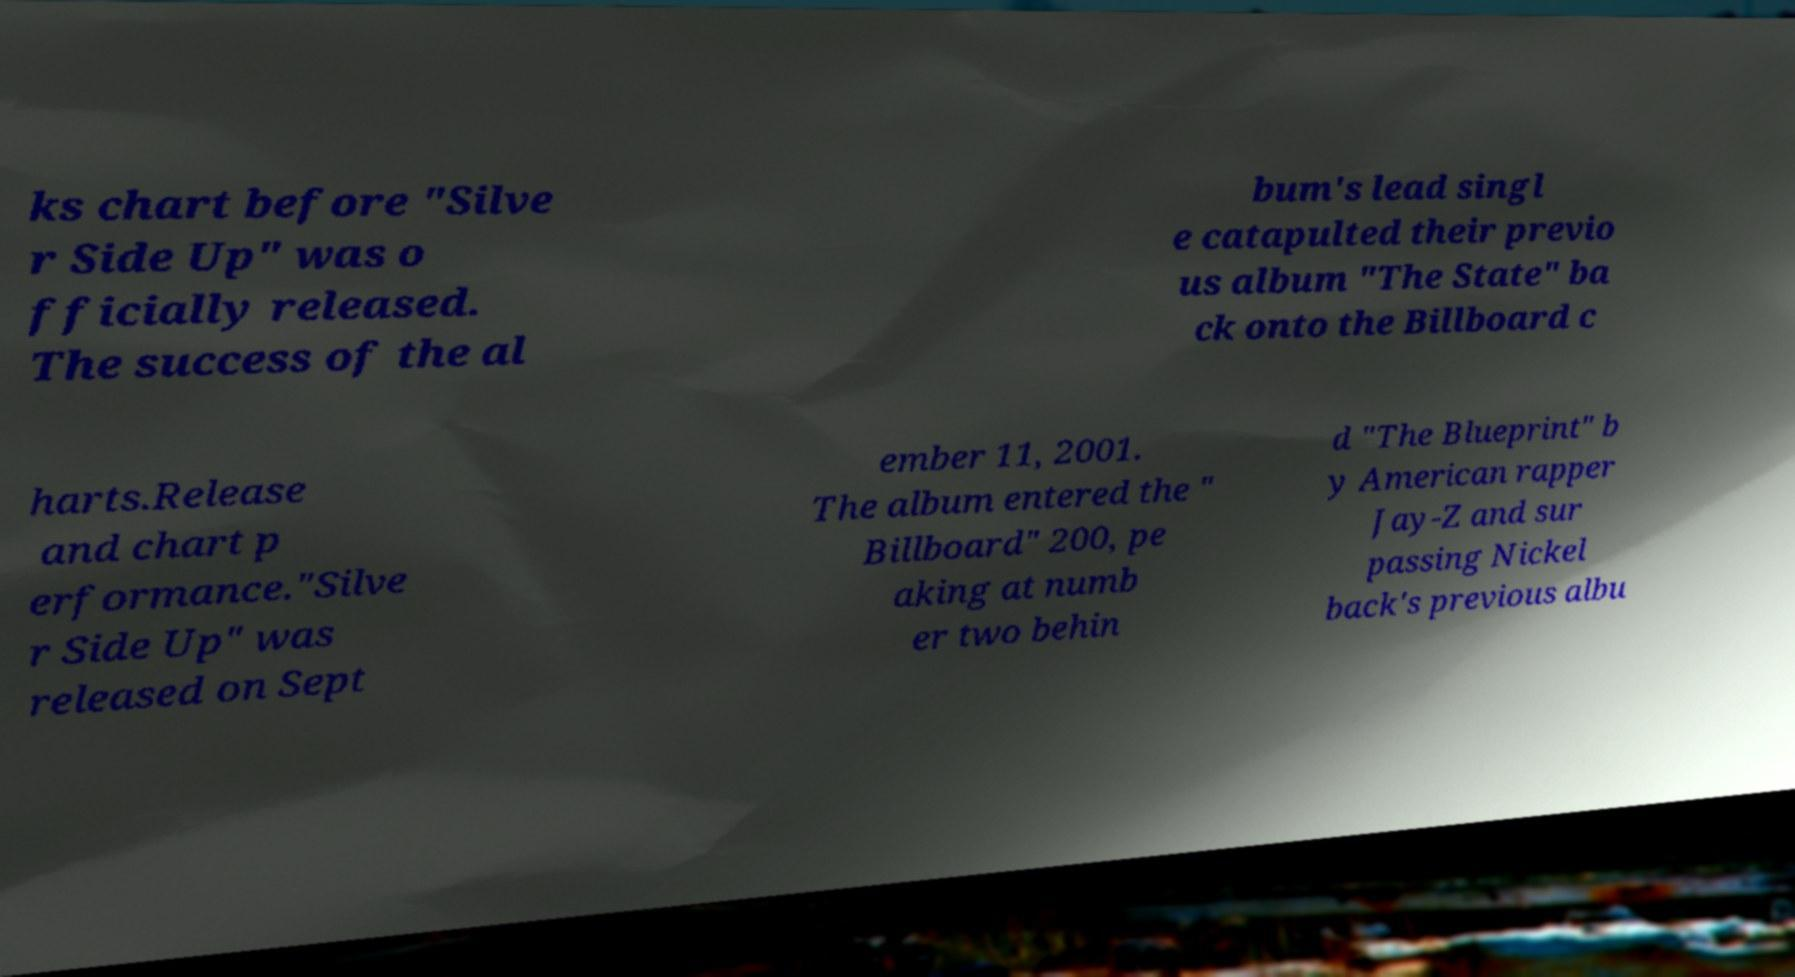For documentation purposes, I need the text within this image transcribed. Could you provide that? ks chart before "Silve r Side Up" was o fficially released. The success of the al bum's lead singl e catapulted their previo us album "The State" ba ck onto the Billboard c harts.Release and chart p erformance."Silve r Side Up" was released on Sept ember 11, 2001. The album entered the " Billboard" 200, pe aking at numb er two behin d "The Blueprint" b y American rapper Jay-Z and sur passing Nickel back's previous albu 